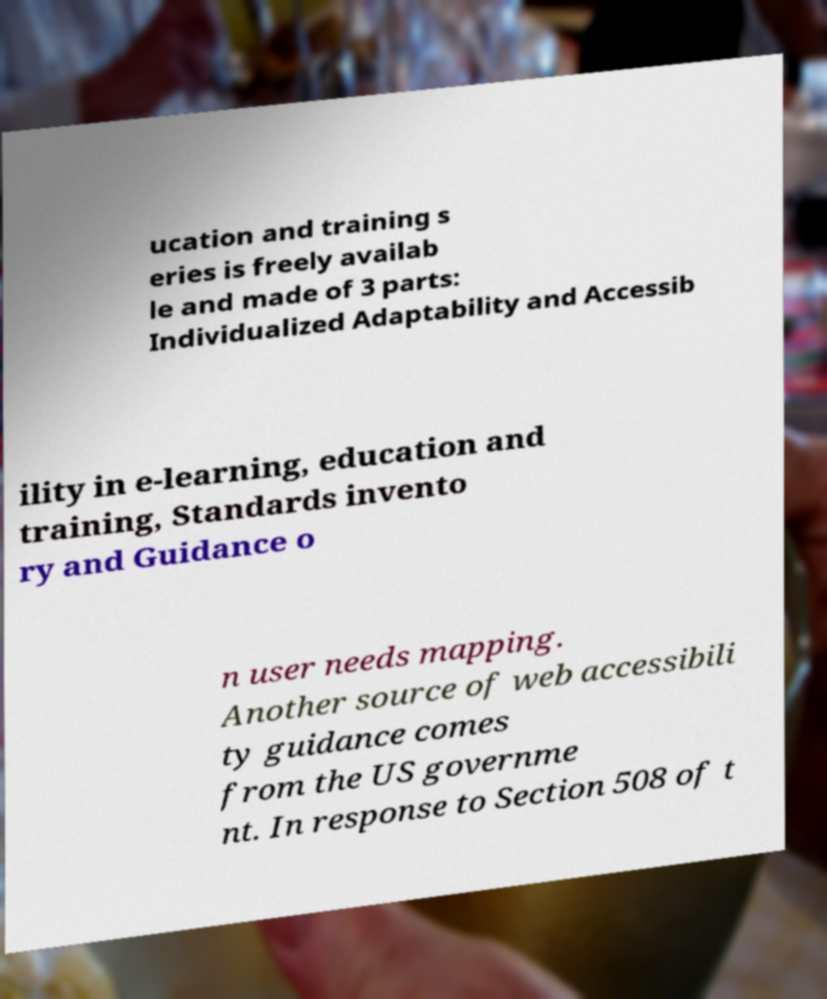Could you extract and type out the text from this image? ucation and training s eries is freely availab le and made of 3 parts: Individualized Adaptability and Accessib ility in e-learning, education and training, Standards invento ry and Guidance o n user needs mapping. Another source of web accessibili ty guidance comes from the US governme nt. In response to Section 508 of t 